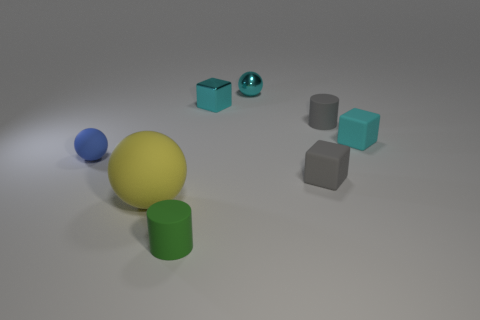What is the color of the small matte object that is the same shape as the big thing? The small matte object that shares the same shape as the largest object, which is a sphere, has a blue color. Specifically, it's a smaller blue sphere in comparison to the big yellow one. 